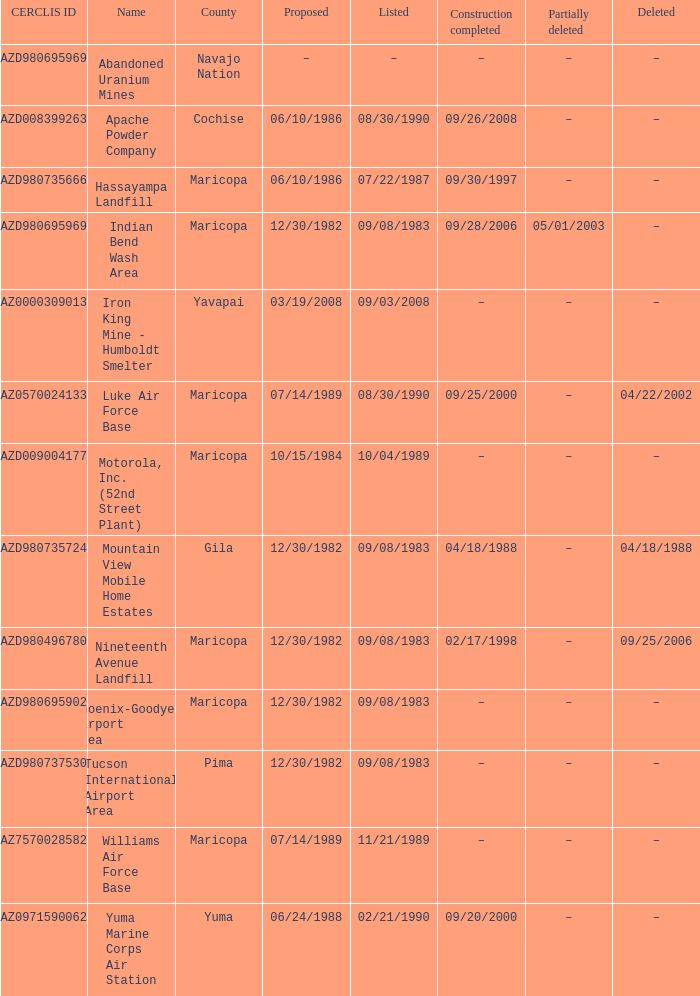At what time was the site with the cerclis id az7570028582 partly removed? –. 